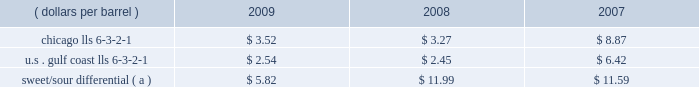Our refining and wholesale marketing gross margin is the difference between the prices of refined products sold and the costs of crude oil and other charge and blendstocks refined , including the costs to transport these inputs to our refineries , the costs of purchased products and manufacturing expenses , including depreciation .
The crack spread is a measure of the difference between market prices for refined products and crude oil , commonly used by the industry as a proxy for the refining margin .
Crack spreads can fluctuate significantly , particularly when prices of refined products do not move in the same relationship as the cost of crude oil .
As a performance benchmark and a comparison with other industry participants , we calculate midwest ( chicago ) and u.s .
Gulf coast crack spreads that we feel most closely track our operations and slate of products .
Posted light louisiana sweet ( 201clls 201d ) prices and a 6-3-2-1 ratio of products ( 6 barrels of crude oil producing 3 barrels of gasoline , 2 barrels of distillate and 1 barrel of residual fuel ) are used for the crack spread calculation .
Our refineries can process significant amounts of sour crude oil which typically can be purchased at a discount to sweet crude oil .
The amount of this discount , the sweet/sour differential , can vary significantly causing our refining and wholesale marketing gross margin to differ from the crack spreads which are based upon sweet crude .
In general , a larger sweet/sour differential will enhance our refining and wholesale marketing gross margin .
In 2009 , the sweet/sour differential narrowed , due to a variety of worldwide economic and petroleum industry related factors , primarily related to lower hydrocarbon demand .
Sour crude accounted for 50 percent , 52 percent and 54 percent of our crude oil processed in 2009 , 2008 and 2007 .
The table lists calculated average crack spreads for the midwest ( chicago ) and gulf coast markets and the sweet/sour differential for the past three years .
( dollars per barrel ) 2009 2008 2007 .
Sweet/sour differential ( a ) $ 5.82 $ 11.99 $ 11.59 ( a ) calculated using the following mix of crude types as compared to lls. : 15% ( 15 % ) arab light , 20% ( 20 % ) kuwait , 10% ( 10 % ) maya , 15% ( 15 % ) western canadian select , 40% ( 40 % ) mars .
In addition to the market changes indicated by the crack spreads and sweet/sour differential , our refining and wholesale marketing gross margin is impacted by factors such as : 2022 the types of crude oil and other charge and blendstocks processed , 2022 the selling prices realized for refined products , 2022 the impact of commodity derivative instruments used to manage price risk , 2022 the cost of products purchased for resale , and 2022 changes in manufacturing costs , which include depreciation .
Manufacturing costs are primarily driven by the cost of energy used by our refineries and the level of maintenance costs .
Planned turnaround and major maintenance activities were completed at our catlettsburg , garyville , and robinson refineries in 2009 .
We performed turnaround and major maintenance activities at our robinson , catlettsburg , garyville and canton refineries in 2008 and at our catlettsburg , robinson and st .
Paul park refineries in 2007 .
Our retail marketing gross margin for gasoline and distillates , which is the difference between the ultimate price paid by consumers and the cost of refined products , including secondary transportation and consumer excise taxes , also impacts rm&t segment profitability .
There are numerous factors including local competition , seasonal demand fluctuations , the available wholesale supply , the level of economic activity in our marketing areas and weather conditions that impact gasoline and distillate demand throughout the year .
Refined product demand increased for several years until 2008 when it decreased due to the combination of significant increases in retail petroleum prices , a broad slowdown in general economic activity , and the impact of increased ethanol blending into gasoline .
In 2009 refined product demand continued to decline .
For our marketing area , we estimate a gasoline demand decline of about one percent and a distillate demand decline of about 12 percent from 2008 levels .
Market demand declines for gasoline and distillates generally reduce the product margin we can realize .
We also estimate gasoline and distillate demand in our marketing area decreased about three percent in 2008 compared to 2007 levels .
The gross margin on merchandise sold at retail outlets has been historically less volatile. .
By what percentage did the average crack spread for sweet/sour differential decrease from 2007 to 2009? 
Computations: ((5.82 - 11.59) / 11.59)
Answer: -0.49784. 